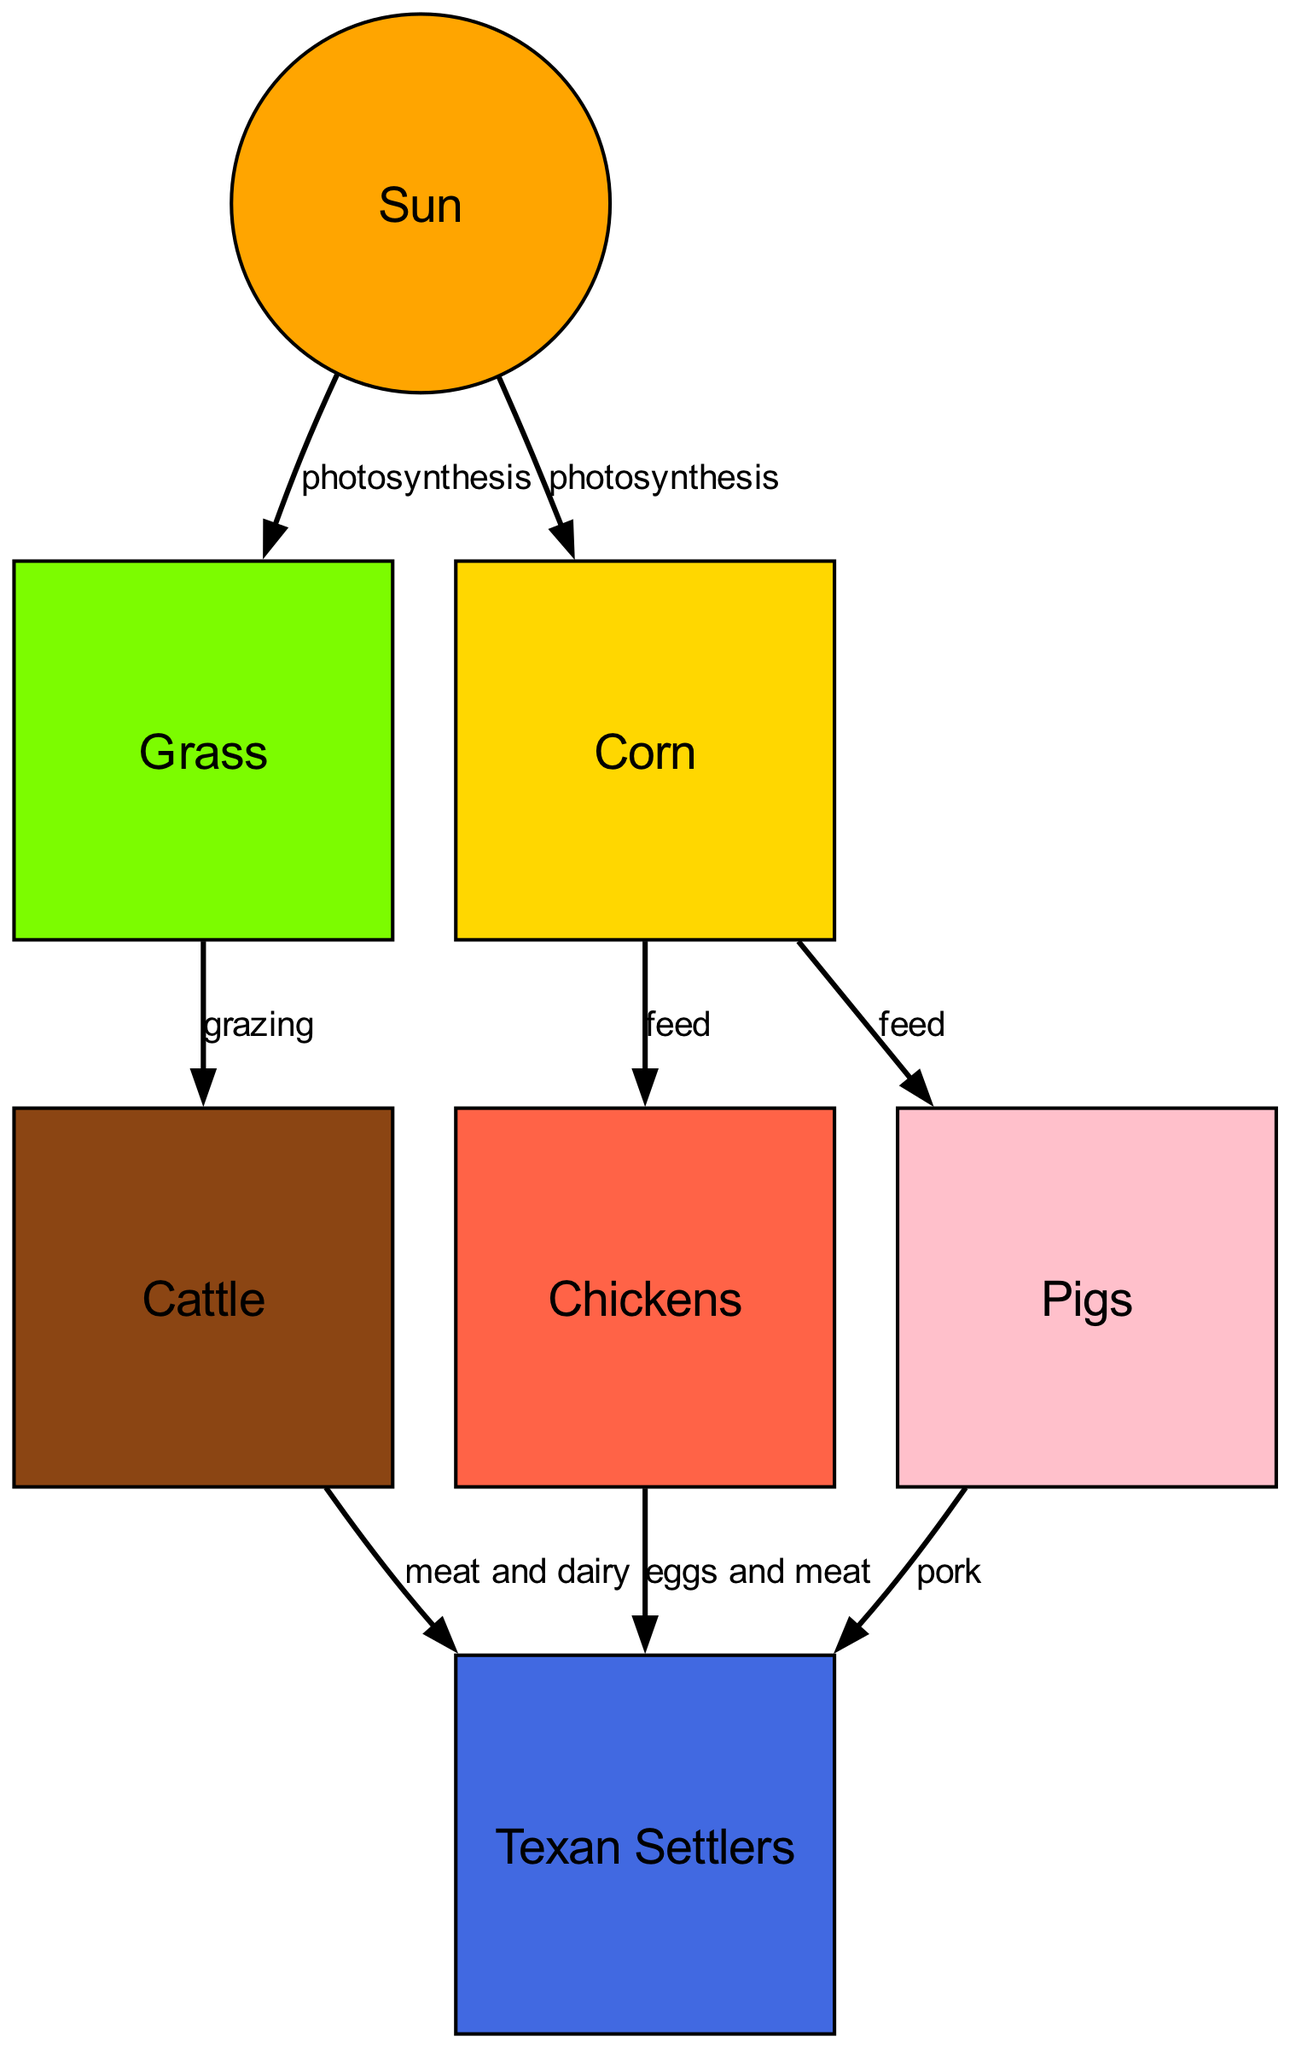What is the primary source of energy in the food chain? The diagram shows the "Sun" as the first node, indicating that it is the primary source of energy through the process of photosynthesis, which fuels the growth of plants like grass and corn.
Answer: Sun What type of food do cattle consume? According to the diagram, the "grazing" relationship links "grass" to "cattle", meaning cattle eat grass as their primary food source.
Answer: Grass How many domesticated animals are present in the food chain? The diagram shows three domesticated animals: cattle, chickens, and pigs, which are all listed as nodes. Therefore, the total count is three.
Answer: Three What do chickens provide to Texans? The edge labeled "eggs and meat" connects "chickens" to "humans", indicating that chickens provide both eggs and meat for Texans.
Answer: Eggs and meat Which plant feeds pigs? The diagram indicates that pigs are fed by "corn", as shown by the edge that connects "corn" to "pigs" labeled "feed".
Answer: Corn What do Texan settlers primarily derive from cattle? The diagram specifies that Texan settlers obtain "meat and dairy" from cattle, as shown in the edge connecting "cattle" to "humans".
Answer: Meat and dairy How is corn utilized in this food chain? The diagram shows that corn is fed to both pigs and chickens, indicating it is a vital food source for these domesticated animals.
Answer: Feed Which animal in this chain produces pork? The edge labeled "pork" connects "pigs" to "humans", indicating that pigs are the animals that produce pork for Texan settlers.
Answer: Pigs What is the relationship between grass and cattle? The diagram displays the edge labeled "grazing" that connects "grass" to "cattle", explaining their direct relationship as food source and consumer.
Answer: Grazing 